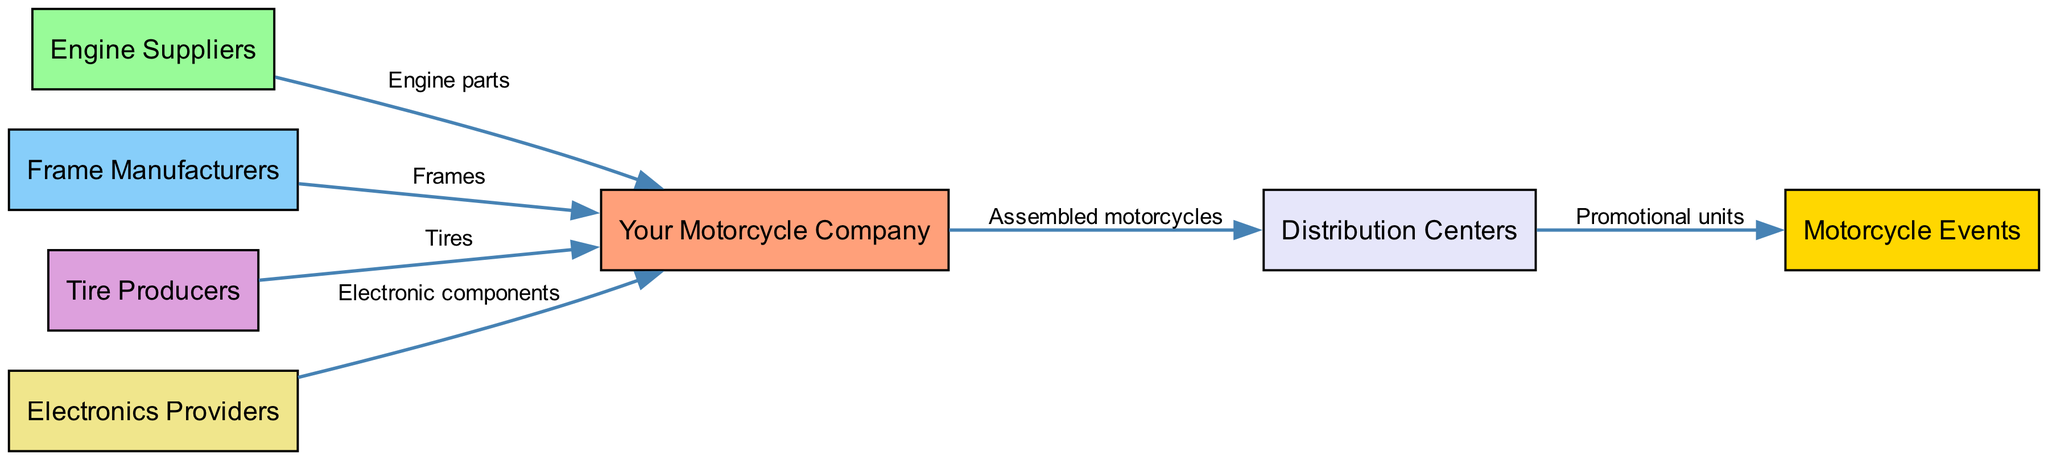What is the total number of nodes in the supply chain diagram? Count the number of unique entities represented in the diagram. The nodes in the diagram include: Your Motorcycle Company, Engine Suppliers, Frame Manufacturers, Tire Producers, Electronics Providers, Distribution Centers, and Motorcycle Events, totaling 7 nodes.
Answer: 7 Which node supplies engine parts to Your Motorcycle Company? Look for the edge that originates from Engine Suppliers and connects to Your Motorcycle Company. The diagram indicates that the Engine Suppliers node provides engine parts directly to the Your Motorcycle Company node.
Answer: Engine Suppliers What type of products does the Distribution Center handle from Your Motorcycle Company? Analyze the edge that goes from Your Motorcycle Company to the Distribution Centers. The edge is labeled "Assembled motorcycles," indicating the type of products sent from Your Motorcycle Company to the Distribution Center.
Answer: Assembled motorcycles Which node represents an event opportunity for promotional activities? Identify the node that specifically is labeled as hosting events. The Diagram lists Motorcycle Events as the node that stands for event opportunities to showcase motorcycles and promote the brand.
Answer: Motorcycle Events How many distinct types of suppliers are listed in the diagram? Evaluate the nodes that represent suppliers. The distinct types of suppliers identified are: Engine Suppliers, Frame Manufacturers, Tire Producers, and Electronics Providers. A total of 4 distinct types are listed.
Answer: 4 What flow occurs from the Distribution Centers to the Motorcycle Events? Trace the edge from Distribution Centers to Motorcycle Events. The edge specifies "Promotional units," indicating that the Distribution Centers send promotional units to the Motorcycle Events.
Answer: Promotional units Which node connects all the suppliers to Your Motorcycle Company? Identify the common endpoint in the edges connecting the suppliers. Each edge for Engine Suppliers, Frame Manufacturers, Tire Producers, and Electronics Providers points to Your Motorcycle Company, making it the central node that connects all suppliers.
Answer: Your Motorcycle Company 